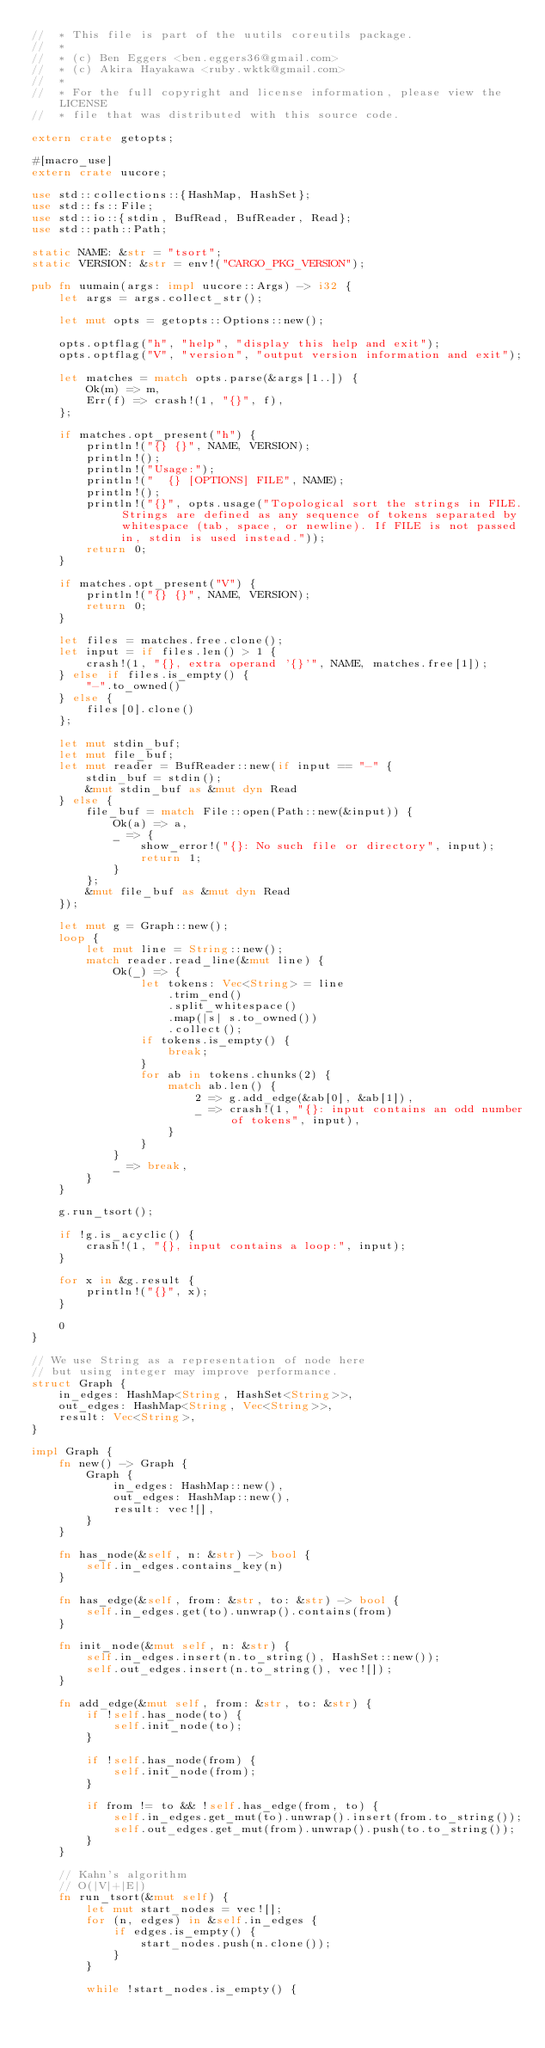Convert code to text. <code><loc_0><loc_0><loc_500><loc_500><_Rust_>//  * This file is part of the uutils coreutils package.
//  *
//  * (c) Ben Eggers <ben.eggers36@gmail.com>
//  * (c) Akira Hayakawa <ruby.wktk@gmail.com>
//  *
//  * For the full copyright and license information, please view the LICENSE
//  * file that was distributed with this source code.

extern crate getopts;

#[macro_use]
extern crate uucore;

use std::collections::{HashMap, HashSet};
use std::fs::File;
use std::io::{stdin, BufRead, BufReader, Read};
use std::path::Path;

static NAME: &str = "tsort";
static VERSION: &str = env!("CARGO_PKG_VERSION");

pub fn uumain(args: impl uucore::Args) -> i32 {
    let args = args.collect_str();

    let mut opts = getopts::Options::new();

    opts.optflag("h", "help", "display this help and exit");
    opts.optflag("V", "version", "output version information and exit");

    let matches = match opts.parse(&args[1..]) {
        Ok(m) => m,
        Err(f) => crash!(1, "{}", f),
    };

    if matches.opt_present("h") {
        println!("{} {}", NAME, VERSION);
        println!();
        println!("Usage:");
        println!("  {} [OPTIONS] FILE", NAME);
        println!();
        println!("{}", opts.usage("Topological sort the strings in FILE. Strings are defined as any sequence of tokens separated by whitespace (tab, space, or newline). If FILE is not passed in, stdin is used instead."));
        return 0;
    }

    if matches.opt_present("V") {
        println!("{} {}", NAME, VERSION);
        return 0;
    }

    let files = matches.free.clone();
    let input = if files.len() > 1 {
        crash!(1, "{}, extra operand '{}'", NAME, matches.free[1]);
    } else if files.is_empty() {
        "-".to_owned()
    } else {
        files[0].clone()
    };

    let mut stdin_buf;
    let mut file_buf;
    let mut reader = BufReader::new(if input == "-" {
        stdin_buf = stdin();
        &mut stdin_buf as &mut dyn Read
    } else {
        file_buf = match File::open(Path::new(&input)) {
            Ok(a) => a,
            _ => {
                show_error!("{}: No such file or directory", input);
                return 1;
            }
        };
        &mut file_buf as &mut dyn Read
    });

    let mut g = Graph::new();
    loop {
        let mut line = String::new();
        match reader.read_line(&mut line) {
            Ok(_) => {
                let tokens: Vec<String> = line
                    .trim_end()
                    .split_whitespace()
                    .map(|s| s.to_owned())
                    .collect();
                if tokens.is_empty() {
                    break;
                }
                for ab in tokens.chunks(2) {
                    match ab.len() {
                        2 => g.add_edge(&ab[0], &ab[1]),
                        _ => crash!(1, "{}: input contains an odd number of tokens", input),
                    }
                }
            }
            _ => break,
        }
    }

    g.run_tsort();

    if !g.is_acyclic() {
        crash!(1, "{}, input contains a loop:", input);
    }

    for x in &g.result {
        println!("{}", x);
    }

    0
}

// We use String as a representation of node here
// but using integer may improve performance.
struct Graph {
    in_edges: HashMap<String, HashSet<String>>,
    out_edges: HashMap<String, Vec<String>>,
    result: Vec<String>,
}

impl Graph {
    fn new() -> Graph {
        Graph {
            in_edges: HashMap::new(),
            out_edges: HashMap::new(),
            result: vec![],
        }
    }

    fn has_node(&self, n: &str) -> bool {
        self.in_edges.contains_key(n)
    }

    fn has_edge(&self, from: &str, to: &str) -> bool {
        self.in_edges.get(to).unwrap().contains(from)
    }

    fn init_node(&mut self, n: &str) {
        self.in_edges.insert(n.to_string(), HashSet::new());
        self.out_edges.insert(n.to_string(), vec![]);
    }

    fn add_edge(&mut self, from: &str, to: &str) {
        if !self.has_node(to) {
            self.init_node(to);
        }

        if !self.has_node(from) {
            self.init_node(from);
        }

        if from != to && !self.has_edge(from, to) {
            self.in_edges.get_mut(to).unwrap().insert(from.to_string());
            self.out_edges.get_mut(from).unwrap().push(to.to_string());
        }
    }

    // Kahn's algorithm
    // O(|V|+|E|)
    fn run_tsort(&mut self) {
        let mut start_nodes = vec![];
        for (n, edges) in &self.in_edges {
            if edges.is_empty() {
                start_nodes.push(n.clone());
            }
        }

        while !start_nodes.is_empty() {</code> 